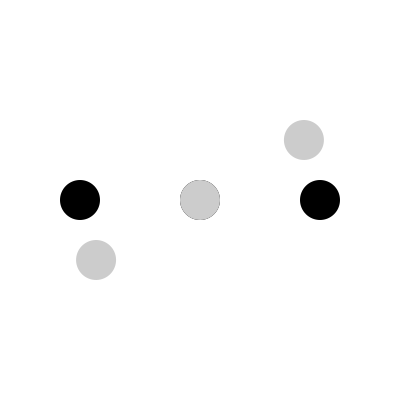How many degrees counterclockwise should the black Goo Goo Dolls logo be rotated to match the orientation of the gray target logo? To solve this problem, we need to follow these steps:

1. Observe the original black logo and the target gray logo.
2. Identify the rotation direction: The question asks for counterclockwise rotation.
3. Visualize the shortest path of rotation from the original to the target position.
4. Count the degrees of rotation:
   - A full circle is 360°
   - The logo appears to be rotated by less than half a circle
   - The rotation seems to be about 5/12 of a full circle
5. Calculate the exact degrees:
   $$(5/12) * 360° = 150°$$

Therefore, the black logo needs to be rotated 150° counterclockwise to match the orientation of the gray target logo.
Answer: 150° 